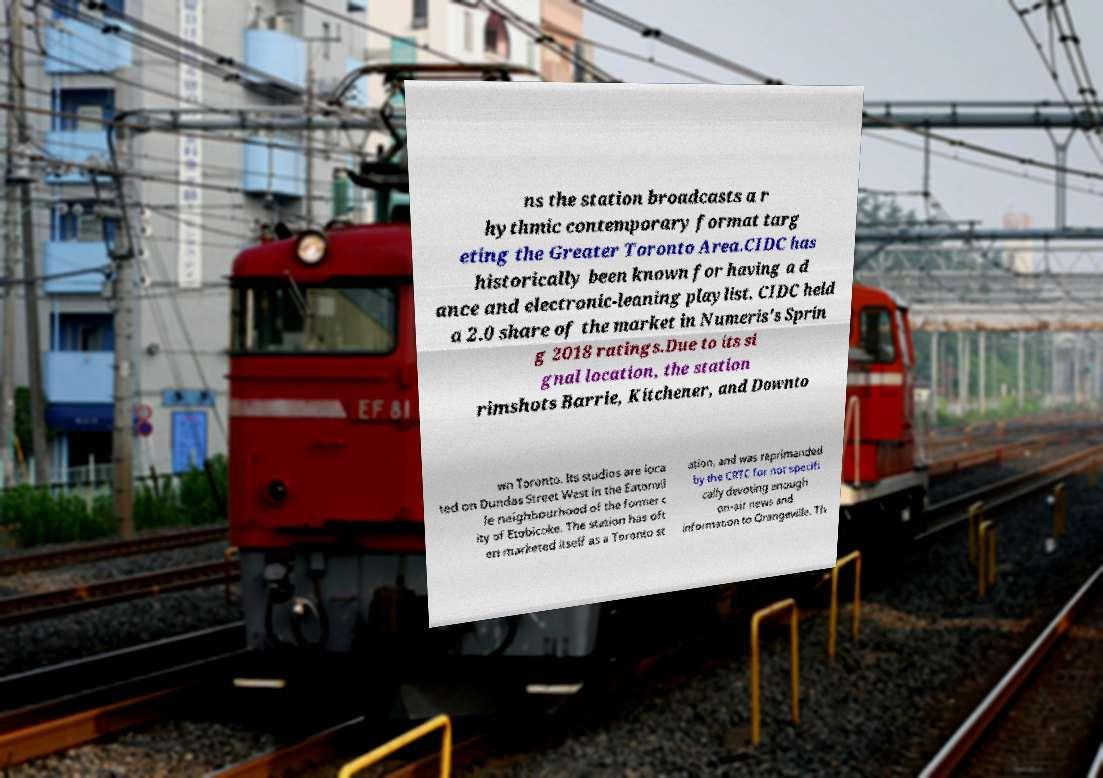Can you read and provide the text displayed in the image?This photo seems to have some interesting text. Can you extract and type it out for me? ns the station broadcasts a r hythmic contemporary format targ eting the Greater Toronto Area.CIDC has historically been known for having a d ance and electronic-leaning playlist. CIDC held a 2.0 share of the market in Numeris's Sprin g 2018 ratings.Due to its si gnal location, the station rimshots Barrie, Kitchener, and Downto wn Toronto. Its studios are loca ted on Dundas Street West in the Eatonvil le neighbourhood of the former c ity of Etobicoke. The station has oft en marketed itself as a Toronto st ation, and was reprimanded by the CRTC for not specifi cally devoting enough on-air news and information to Orangeville. Th 